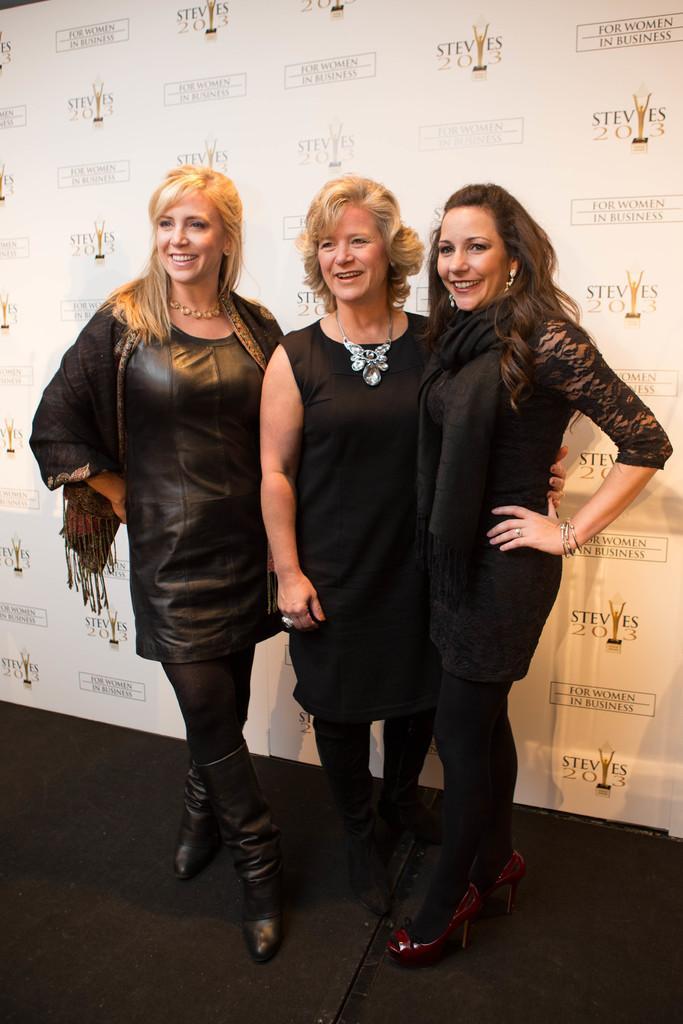Please provide a concise description of this image. Here we can see three women are standing on the floor and smiling. In the background there is a hoarding. 